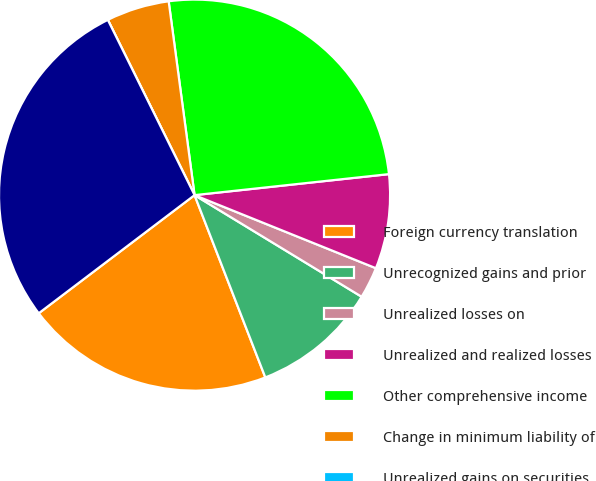<chart> <loc_0><loc_0><loc_500><loc_500><pie_chart><fcel>Foreign currency translation<fcel>Unrecognized gains and prior<fcel>Unrealized losses on<fcel>Unrealized and realized losses<fcel>Other comprehensive income<fcel>Change in minimum liability of<fcel>Unrealized gains on securities<fcel>Other comprehensive loss<nl><fcel>20.57%<fcel>10.41%<fcel>2.6%<fcel>7.81%<fcel>25.4%<fcel>5.2%<fcel>0.0%<fcel>28.01%<nl></chart> 